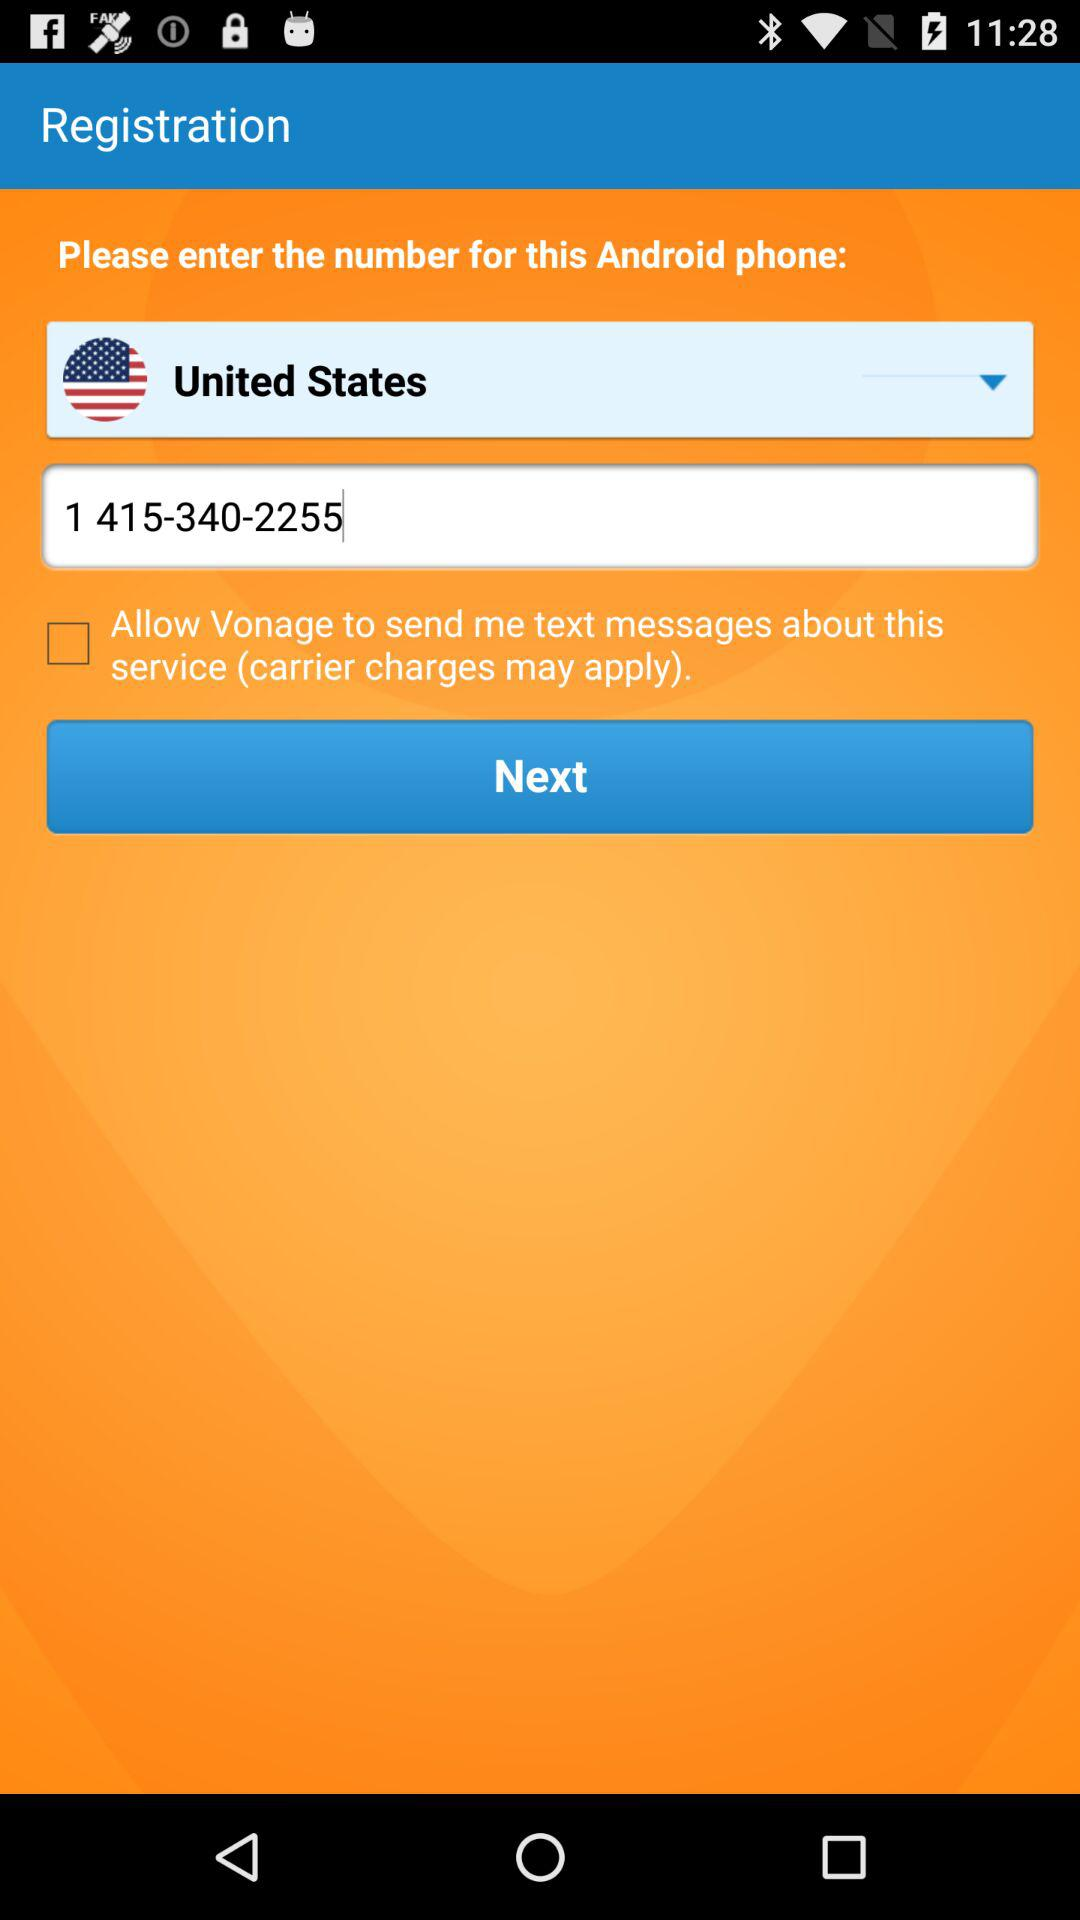What is the selected country? The selected country is "United States". 